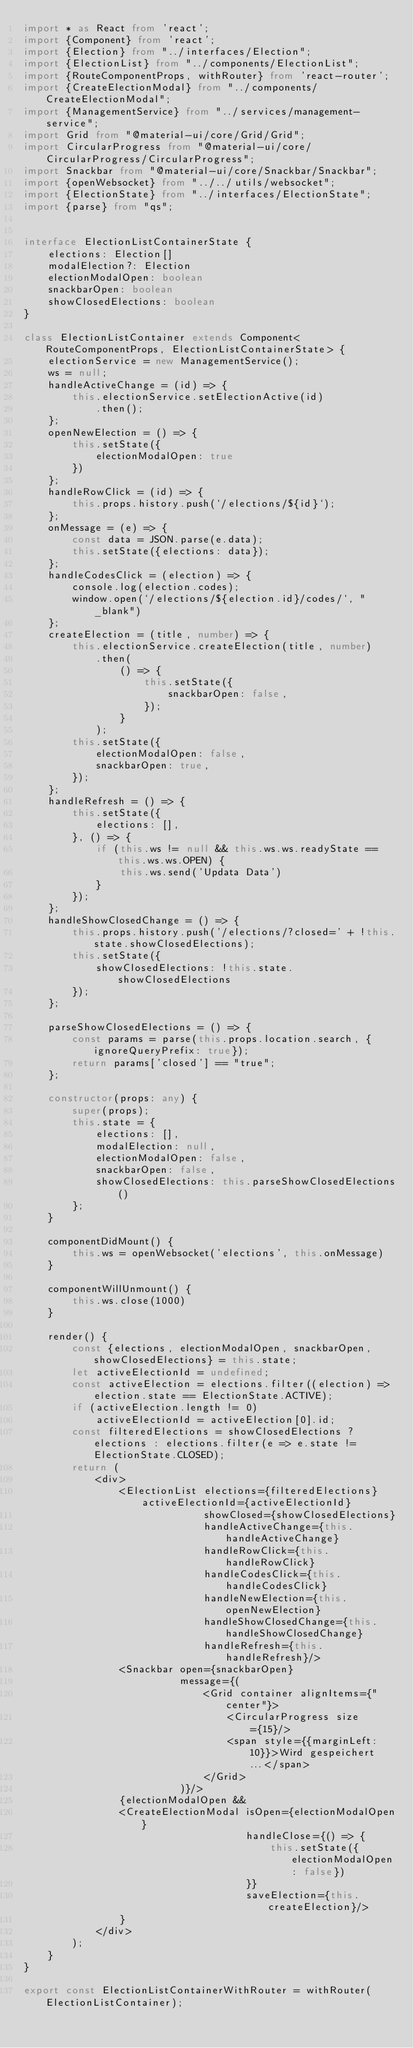Convert code to text. <code><loc_0><loc_0><loc_500><loc_500><_TypeScript_>import * as React from 'react';
import {Component} from 'react';
import {Election} from "../interfaces/Election";
import {ElectionList} from "../components/ElectionList";
import {RouteComponentProps, withRouter} from 'react-router';
import {CreateElectionModal} from "../components/CreateElectionModal";
import {ManagementService} from "../services/management-service";
import Grid from "@material-ui/core/Grid/Grid";
import CircularProgress from "@material-ui/core/CircularProgress/CircularProgress";
import Snackbar from "@material-ui/core/Snackbar/Snackbar";
import {openWebsocket} from "../../utils/websocket";
import {ElectionState} from "../interfaces/ElectionState";
import {parse} from "qs";


interface ElectionListContainerState {
    elections: Election[]
    modalElection?: Election
    electionModalOpen: boolean
    snackbarOpen: boolean
    showClosedElections: boolean
}

class ElectionListContainer extends Component<RouteComponentProps, ElectionListContainerState> {
    electionService = new ManagementService();
    ws = null;
    handleActiveChange = (id) => {
        this.electionService.setElectionActive(id)
            .then();
    };
    openNewElection = () => {
        this.setState({
            electionModalOpen: true
        })
    };
    handleRowClick = (id) => {
        this.props.history.push(`/elections/${id}`);
    };
    onMessage = (e) => {
        const data = JSON.parse(e.data);
        this.setState({elections: data});
    };
    handleCodesClick = (election) => {
        console.log(election.codes);
        window.open(`/elections/${election.id}/codes/`, "_blank")
    };
    createElection = (title, number) => {
        this.electionService.createElection(title, number)
            .then(
                () => {
                    this.setState({
                        snackbarOpen: false,
                    });
                }
            );
        this.setState({
            electionModalOpen: false,
            snackbarOpen: true,
        });
    };
    handleRefresh = () => {
        this.setState({
            elections: [],
        }, () => {
            if (this.ws != null && this.ws.ws.readyState == this.ws.ws.OPEN) {
                this.ws.send('Updata Data')
            }
        });
    };
    handleShowClosedChange = () => {
        this.props.history.push('/elections/?closed=' + !this.state.showClosedElections);
        this.setState({
            showClosedElections: !this.state.showClosedElections
        });
    };

    parseShowClosedElections = () => {
        const params = parse(this.props.location.search, {ignoreQueryPrefix: true});
        return params['closed'] == "true";
    };

    constructor(props: any) {
        super(props);
        this.state = {
            elections: [],
            modalElection: null,
            electionModalOpen: false,
            snackbarOpen: false,
            showClosedElections: this.parseShowClosedElections()
        };
    }

    componentDidMount() {
        this.ws = openWebsocket('elections', this.onMessage)
    }

    componentWillUnmount() {
        this.ws.close(1000)
    }

    render() {
        const {elections, electionModalOpen, snackbarOpen, showClosedElections} = this.state;
        let activeElectionId = undefined;
        const activeElection = elections.filter((election) => election.state == ElectionState.ACTIVE);
        if (activeElection.length != 0)
            activeElectionId = activeElection[0].id;
        const filteredElections = showClosedElections ? elections : elections.filter(e => e.state != ElectionState.CLOSED);
        return (
            <div>
                <ElectionList elections={filteredElections} activeElectionId={activeElectionId}
                              showClosed={showClosedElections}
                              handleActiveChange={this.handleActiveChange}
                              handleRowClick={this.handleRowClick}
                              handleCodesClick={this.handleCodesClick}
                              handleNewElection={this.openNewElection}
                              handleShowClosedChange={this.handleShowClosedChange}
                              handleRefresh={this.handleRefresh}/>
                <Snackbar open={snackbarOpen}
                          message={(
                              <Grid container alignItems={"center"}>
                                  <CircularProgress size={15}/>
                                  <span style={{marginLeft: 10}}>Wird gespeichert ...</span>
                              </Grid>
                          )}/>
                {electionModalOpen &&
                <CreateElectionModal isOpen={electionModalOpen}
                                     handleClose={() => {
                                         this.setState({electionModalOpen: false})
                                     }}
                                     saveElection={this.createElection}/>
                }
            </div>
        );
    }
}

export const ElectionListContainerWithRouter = withRouter(ElectionListContainer);</code> 